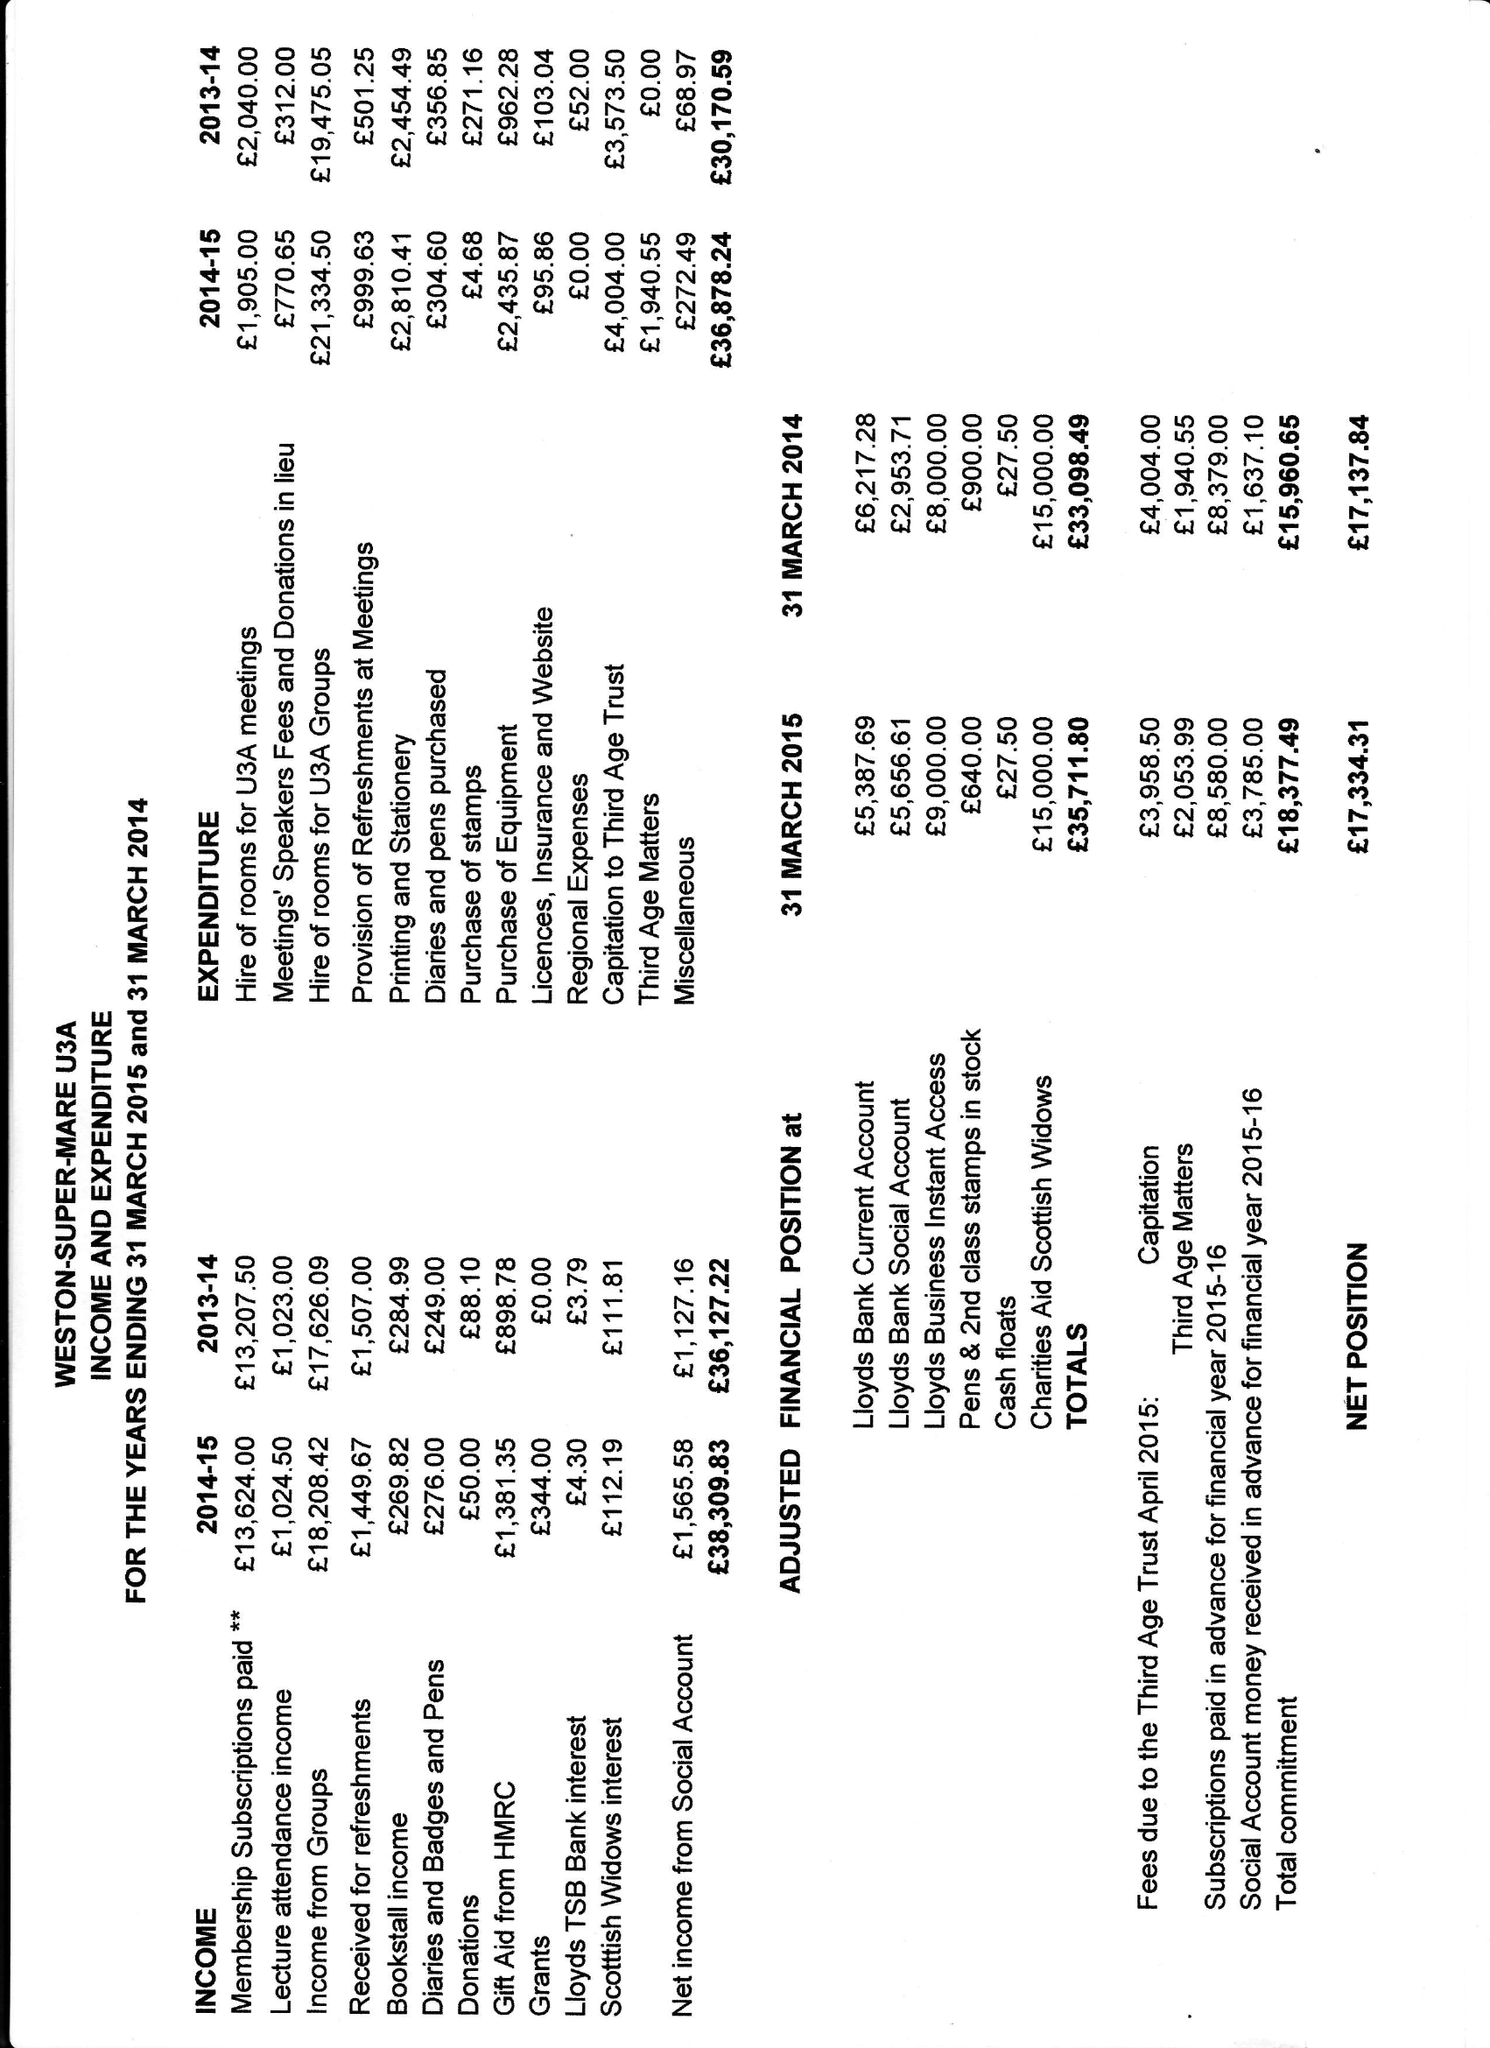What is the value for the address__street_line?
Answer the question using a single word or phrase. None 